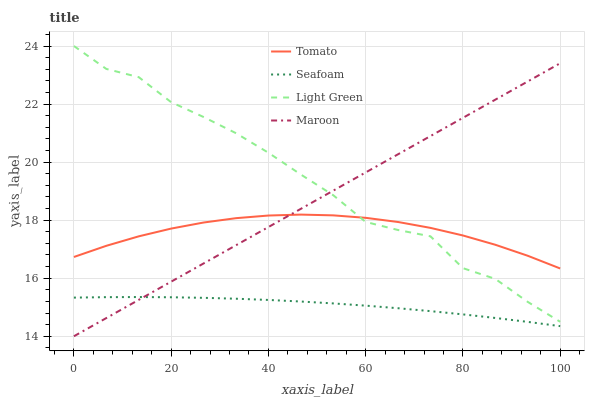Does Seafoam have the minimum area under the curve?
Answer yes or no. Yes. Does Light Green have the maximum area under the curve?
Answer yes or no. Yes. Does Maroon have the minimum area under the curve?
Answer yes or no. No. Does Maroon have the maximum area under the curve?
Answer yes or no. No. Is Maroon the smoothest?
Answer yes or no. Yes. Is Light Green the roughest?
Answer yes or no. Yes. Is Seafoam the smoothest?
Answer yes or no. No. Is Seafoam the roughest?
Answer yes or no. No. Does Maroon have the lowest value?
Answer yes or no. Yes. Does Seafoam have the lowest value?
Answer yes or no. No. Does Light Green have the highest value?
Answer yes or no. Yes. Does Maroon have the highest value?
Answer yes or no. No. Is Seafoam less than Tomato?
Answer yes or no. Yes. Is Tomato greater than Seafoam?
Answer yes or no. Yes. Does Light Green intersect Tomato?
Answer yes or no. Yes. Is Light Green less than Tomato?
Answer yes or no. No. Is Light Green greater than Tomato?
Answer yes or no. No. Does Seafoam intersect Tomato?
Answer yes or no. No. 